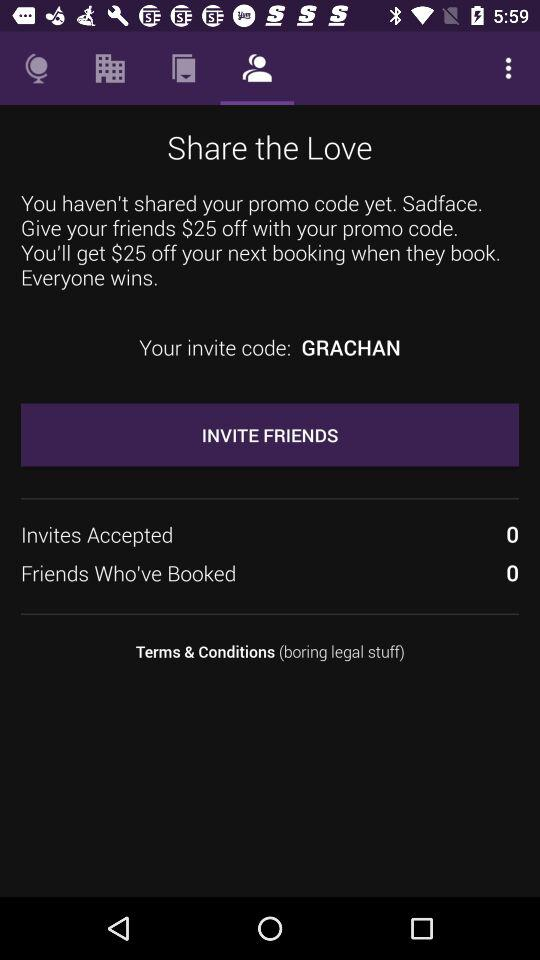What is the count of "Invites Accepted"? The count is 0. 